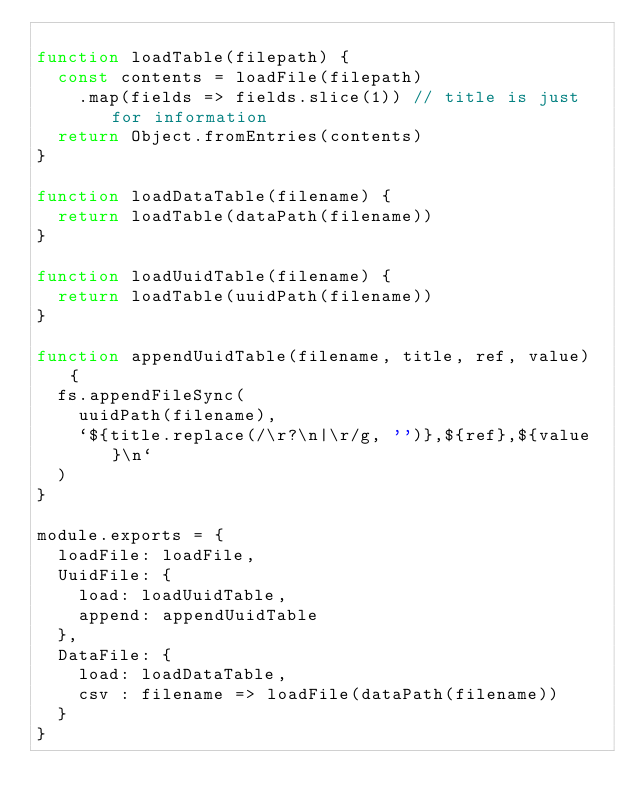<code> <loc_0><loc_0><loc_500><loc_500><_JavaScript_>
function loadTable(filepath) {
  const contents = loadFile(filepath)
    .map(fields => fields.slice(1)) // title is just for information
  return Object.fromEntries(contents)
}

function loadDataTable(filename) {
  return loadTable(dataPath(filename))
}

function loadUuidTable(filename) {
  return loadTable(uuidPath(filename))
}

function appendUuidTable(filename, title, ref, value) {
  fs.appendFileSync(
    uuidPath(filename),
    `${title.replace(/\r?\n|\r/g, '')},${ref},${value}\n`
  )
}

module.exports = {
  loadFile: loadFile,
  UuidFile: {
    load: loadUuidTable,
    append: appendUuidTable
  },
  DataFile: {
    load: loadDataTable,
    csv : filename => loadFile(dataPath(filename))
  }
}
</code> 